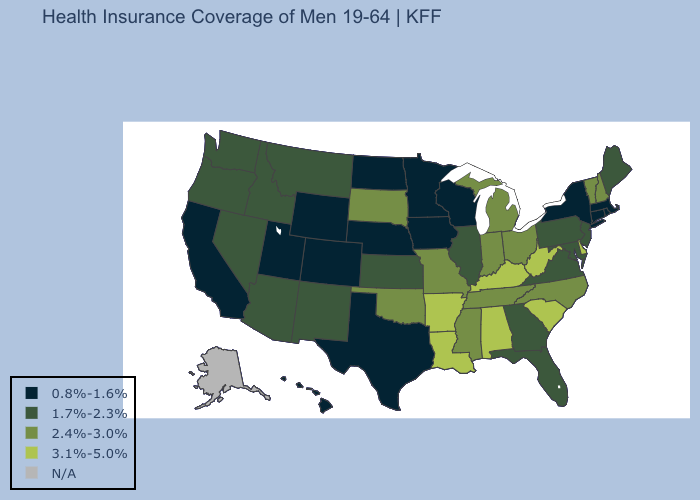What is the value of Illinois?
Answer briefly. 1.7%-2.3%. Which states have the lowest value in the USA?
Answer briefly. California, Colorado, Connecticut, Hawaii, Iowa, Massachusetts, Minnesota, Nebraska, New York, North Dakota, Rhode Island, Texas, Utah, Wisconsin, Wyoming. Does Delaware have the highest value in the USA?
Answer briefly. Yes. Does the first symbol in the legend represent the smallest category?
Keep it brief. Yes. Among the states that border Missouri , which have the lowest value?
Be succinct. Iowa, Nebraska. Among the states that border Kansas , which have the lowest value?
Write a very short answer. Colorado, Nebraska. What is the highest value in states that border Ohio?
Concise answer only. 3.1%-5.0%. Does Vermont have the highest value in the Northeast?
Concise answer only. Yes. How many symbols are there in the legend?
Concise answer only. 5. Which states have the highest value in the USA?
Keep it brief. Alabama, Arkansas, Delaware, Kentucky, Louisiana, South Carolina, West Virginia. Which states have the lowest value in the USA?
Answer briefly. California, Colorado, Connecticut, Hawaii, Iowa, Massachusetts, Minnesota, Nebraska, New York, North Dakota, Rhode Island, Texas, Utah, Wisconsin, Wyoming. What is the value of Wyoming?
Keep it brief. 0.8%-1.6%. Among the states that border Iowa , which have the lowest value?
Keep it brief. Minnesota, Nebraska, Wisconsin. Name the states that have a value in the range 2.4%-3.0%?
Quick response, please. Indiana, Michigan, Mississippi, Missouri, New Hampshire, North Carolina, Ohio, Oklahoma, South Dakota, Tennessee, Vermont. What is the highest value in the South ?
Keep it brief. 3.1%-5.0%. 